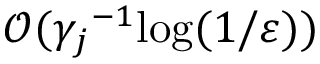Convert formula to latex. <formula><loc_0><loc_0><loc_500><loc_500>\mathcal { O } ( { \gamma _ { j } } ^ { - 1 } \log ( 1 / \varepsilon ) )</formula> 